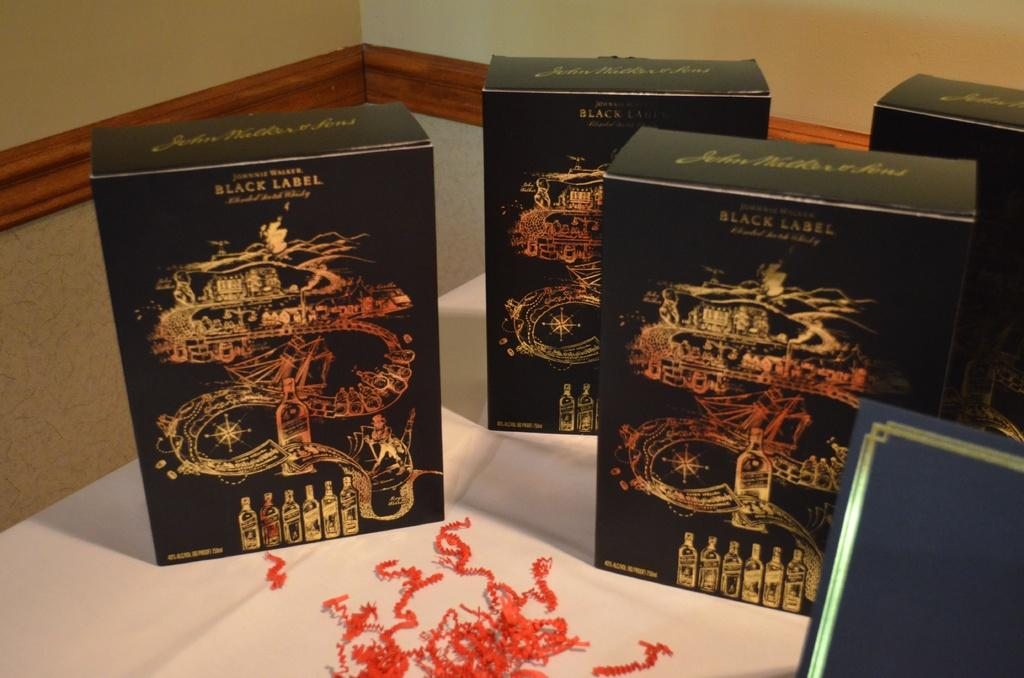Provide a one-sentence caption for the provided image. Elaborately decorated boxes are classified as Black Label versions of the brand. 